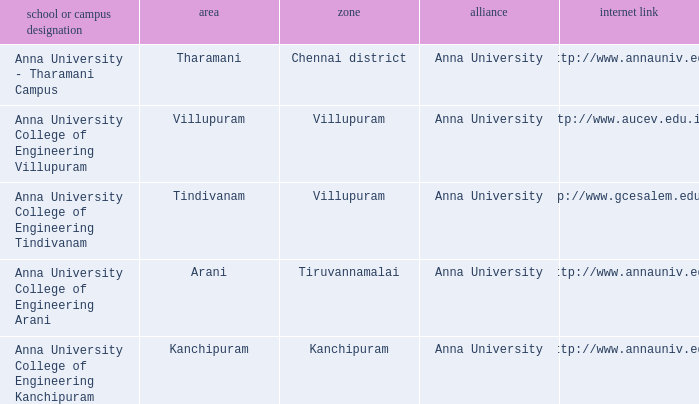What Weblink has a College or Campus Name of anna university college of engineering kanchipuram? Http://www.annauniv.edu. 